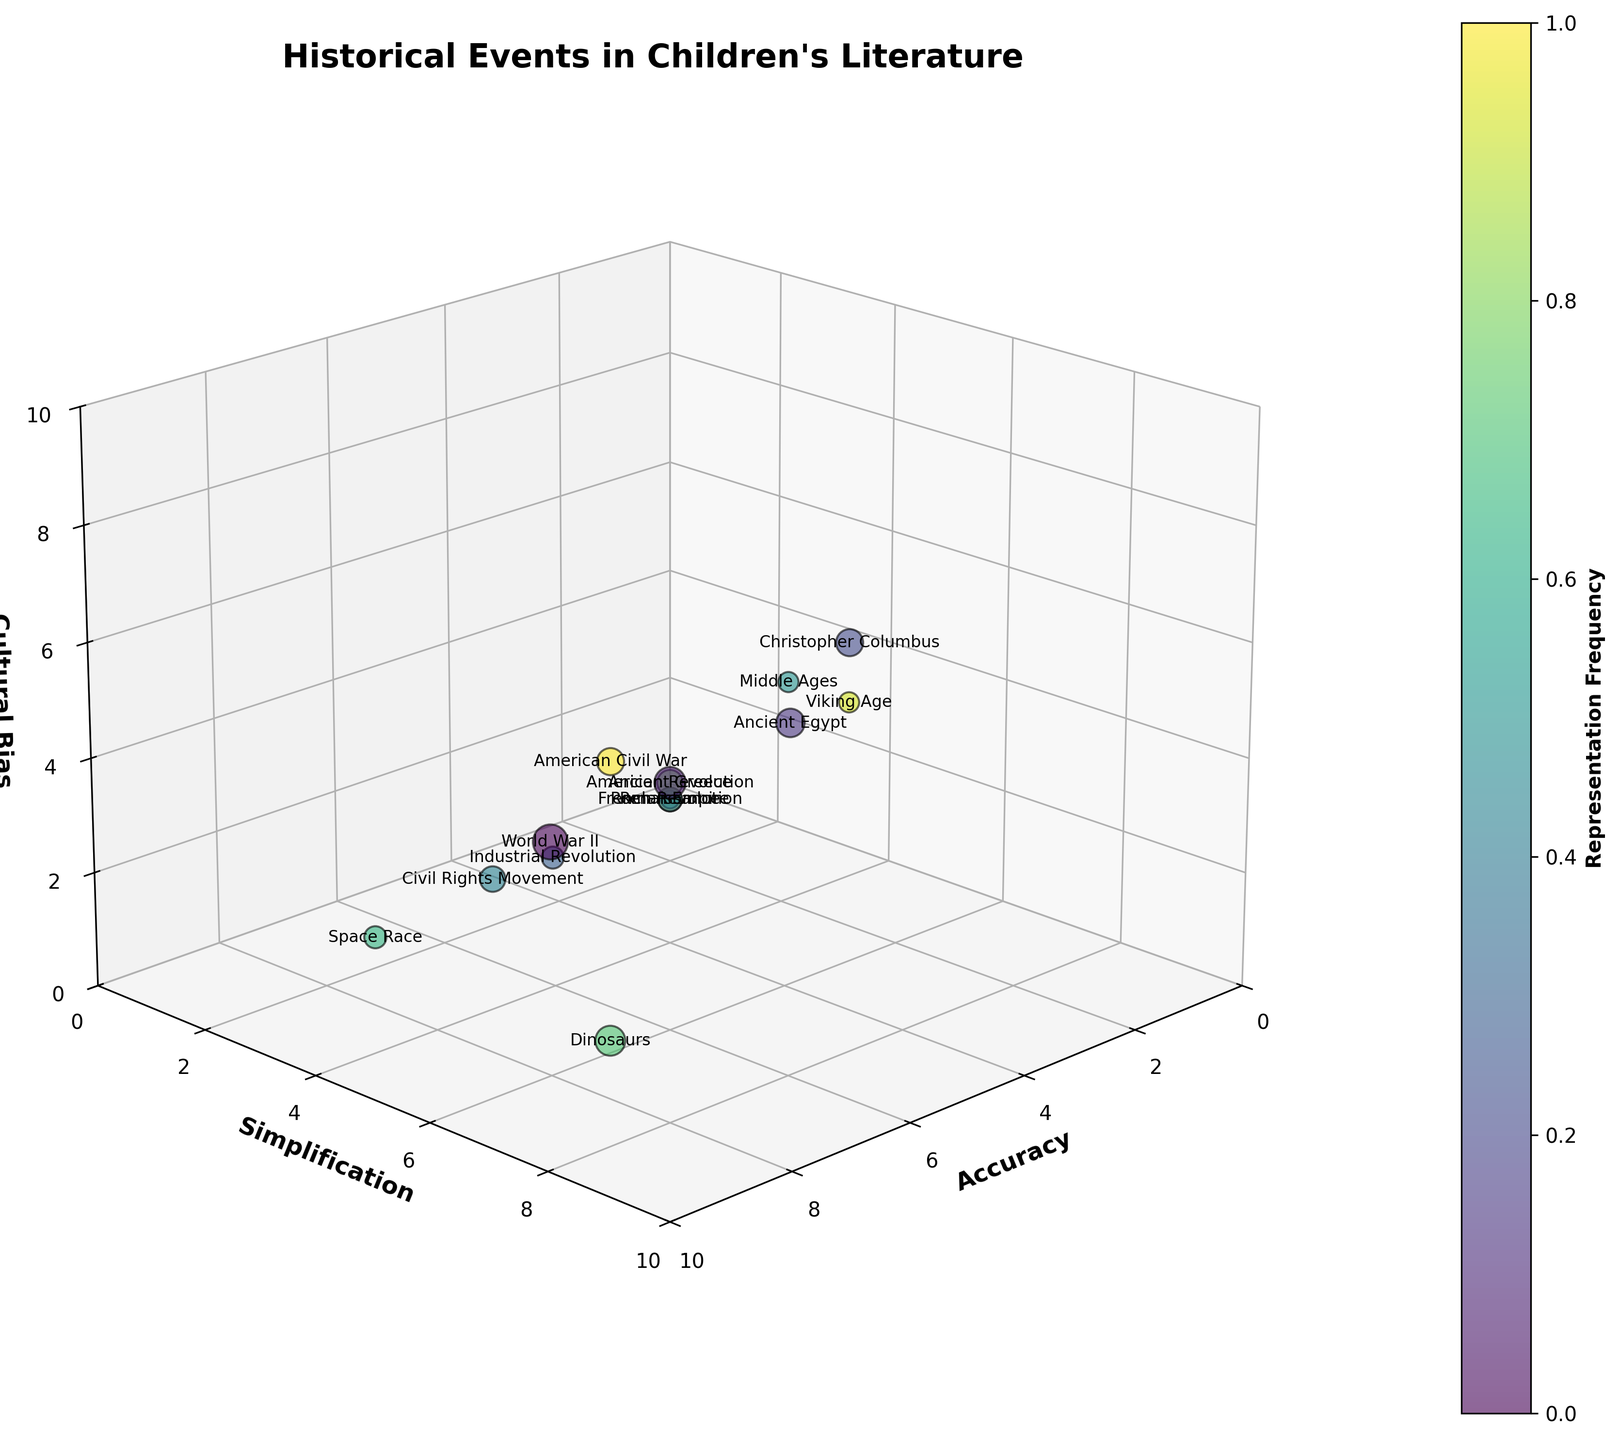How many total events are represented in the chart? To find the total number of events, simply count the unique labels or data points represented on the 3D bubble chart. Each event listed in the data like "World War II" or "American Revolution" is one unique data point. By counting them, we get the total number of events.
Answer: 15 What are the axes labels of the chart? The axes labels are clearly indicated on the chart. The x-axis is labeled "Accuracy", the y-axis is labeled "Simplification", and the z-axis is labeled "Cultural Bias".
Answer: Accuracy, Simplification, Cultural Bias Which historical event has the highest representation frequency? To determine this, look at the bubbles in the chart. The size of the bubble is proportional to its representation frequency. The largest bubble corresponds to the highest frequency. By comparing the sizes, "World War II" has the highest representation frequency of 15.
Answer: World War II Which event has the highest simplification score and what is it? The simplification score can be found along the y-axis. Identify the data point that is positioned highest along the y-axis. "Christopher Columbus" and "Viking Age" both have the highest simplification score of 8.
Answer: Christopher Columbus, Viking Age - 8 What is the relationship between accuracy and cultural bias for "Dinosaurs"? Locate the bubble for "Dinosaurs" in the 3D space, then note its position on the Accuracy and Cultural Bias axes. The accuracy for "Dinosaurs" is 8, and the cultural bias is 1. So, it has high accuracy and very low cultural bias.
Answer: 8 Accuracy, 1 Cultural Bias What is the average cultural bias score of all events? Sum the cultural bias scores for all events: 4, 5, 6, 7, 3, 4, 3, 6, 4, 2, 1, 5, 4, 6, 5. The total sum is 65. Then, divide by the number of events (15). 65 / 15 = approximately 4.33.
Answer: 4.33 Which historical events have a higher accuracy score than the American Revolution? The American Revolution has an accuracy score of 7. Comparing other events, "World War II", "Civil Rights Movement", "Space Race", and "Dinosaurs" have accuracy scores higher than 7.
Answer: World War II, Civil Rights Movement, Space Race, Dinosaurs Group the events with simplification scores equal to or greater than 7. Identify events with simplification scores 7 or higher: "American Revolution" (7), "Ancient Egypt" (8), "Christopher Columbus" (8), "Middle Ages" (7), "Ancient Greece" (7), "Viking Age" (8).
Answer: American Revolution, Ancient Egypt, Christopher Columbus, Middle Ages, Ancient Greece, Viking Age Do any events have the same score for all three dimensions (accuracy, simplification, cultural bias)? Review the scores of each event for accuracy, simplification, and cultural bias. No events have identical values for all three dimensions.
Answer: No What is the most culturally biased event according to the chart? Identify the event with the highest value along the z-axis labeled "Cultural Bias". "Christopher Columbus" has the highest cultural bias score of 7.
Answer: Christopher Columbus 